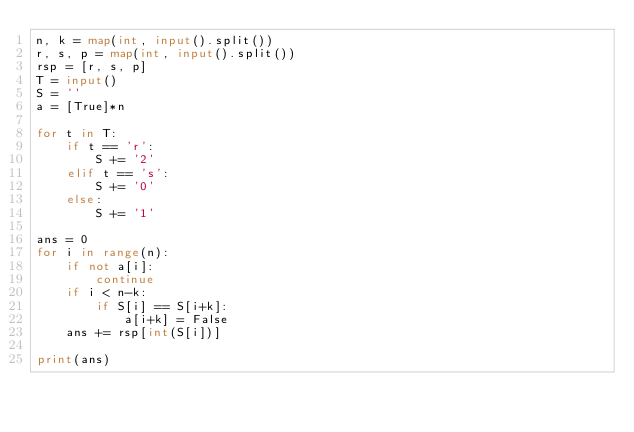<code> <loc_0><loc_0><loc_500><loc_500><_Python_>n, k = map(int, input().split())
r, s, p = map(int, input().split())
rsp = [r, s, p]
T = input()
S = ''
a = [True]*n

for t in T:
    if t == 'r':
        S += '2'
    elif t == 's':
        S += '0'
    else:
        S += '1'

ans = 0
for i in range(n):
    if not a[i]:
        continue
    if i < n-k:
        if S[i] == S[i+k]:
            a[i+k] = False
    ans += rsp[int(S[i])]

print(ans)</code> 